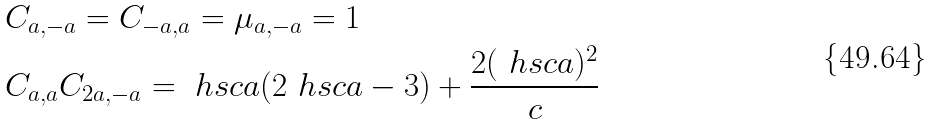Convert formula to latex. <formula><loc_0><loc_0><loc_500><loc_500>& C _ { a , - a } = C _ { - a , a } = \mu _ { a , - a } = 1 \\ & C _ { a , a } C _ { 2 a , - a } = \ h s c { a } ( 2 \ h s c { a } - 3 ) + \frac { 2 ( \ h s c { a } ) ^ { 2 } } { c }</formula> 